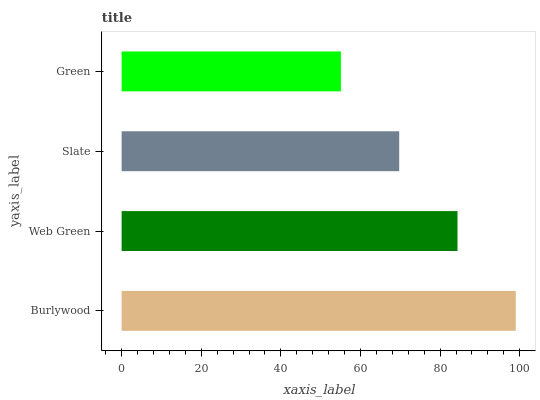Is Green the minimum?
Answer yes or no. Yes. Is Burlywood the maximum?
Answer yes or no. Yes. Is Web Green the minimum?
Answer yes or no. No. Is Web Green the maximum?
Answer yes or no. No. Is Burlywood greater than Web Green?
Answer yes or no. Yes. Is Web Green less than Burlywood?
Answer yes or no. Yes. Is Web Green greater than Burlywood?
Answer yes or no. No. Is Burlywood less than Web Green?
Answer yes or no. No. Is Web Green the high median?
Answer yes or no. Yes. Is Slate the low median?
Answer yes or no. Yes. Is Burlywood the high median?
Answer yes or no. No. Is Burlywood the low median?
Answer yes or no. No. 